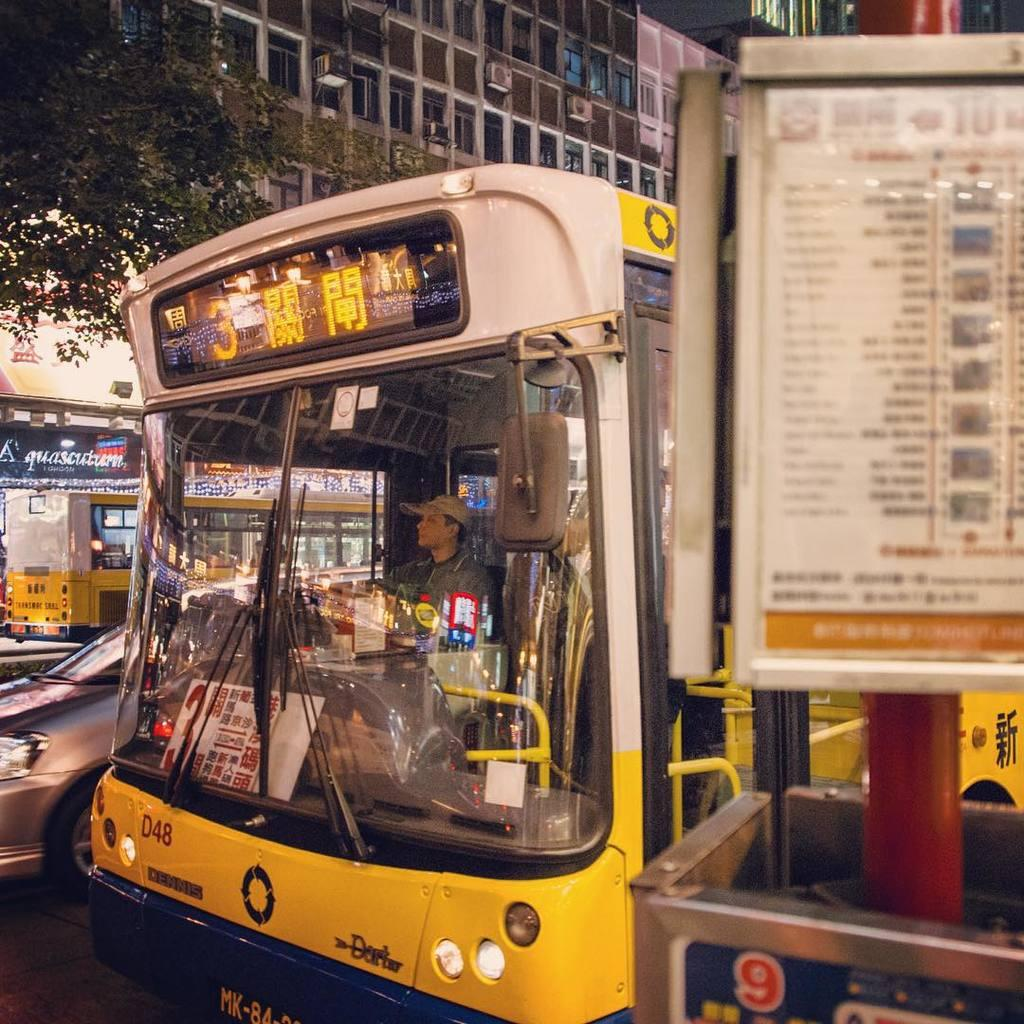<image>
Provide a brief description of the given image. the number 3 bus with the label 'd48' on the front end of it 